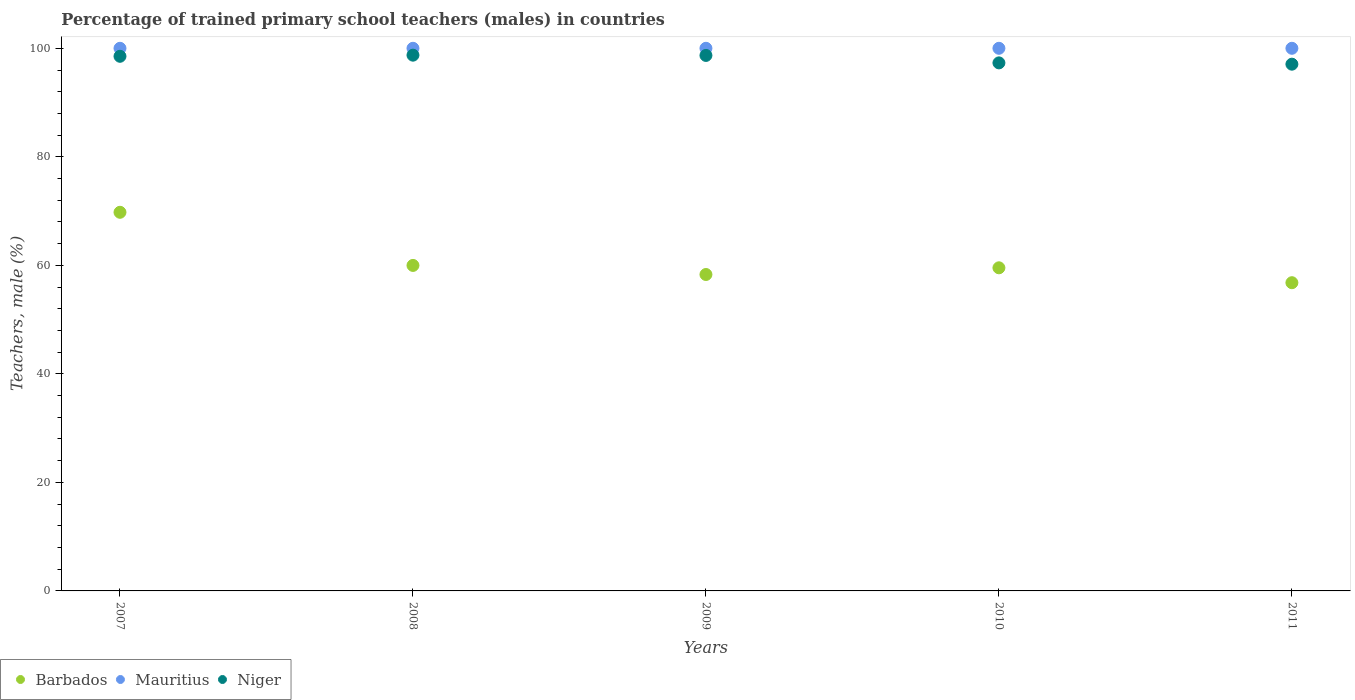Is the number of dotlines equal to the number of legend labels?
Make the answer very short. Yes. What is the percentage of trained primary school teachers (males) in Barbados in 2011?
Provide a succinct answer. 56.8. In which year was the percentage of trained primary school teachers (males) in Mauritius maximum?
Your response must be concise. 2007. What is the total percentage of trained primary school teachers (males) in Niger in the graph?
Ensure brevity in your answer.  490.33. What is the difference between the percentage of trained primary school teachers (males) in Niger in 2008 and that in 2009?
Make the answer very short. 0.05. What is the difference between the percentage of trained primary school teachers (males) in Niger in 2007 and the percentage of trained primary school teachers (males) in Barbados in 2008?
Ensure brevity in your answer.  38.54. What is the average percentage of trained primary school teachers (males) in Barbados per year?
Your answer should be compact. 60.88. In the year 2007, what is the difference between the percentage of trained primary school teachers (males) in Niger and percentage of trained primary school teachers (males) in Barbados?
Your response must be concise. 28.75. What is the ratio of the percentage of trained primary school teachers (males) in Niger in 2008 to that in 2009?
Offer a very short reply. 1. Is the percentage of trained primary school teachers (males) in Niger in 2007 less than that in 2011?
Keep it short and to the point. No. Is the difference between the percentage of trained primary school teachers (males) in Niger in 2009 and 2011 greater than the difference between the percentage of trained primary school teachers (males) in Barbados in 2009 and 2011?
Your answer should be very brief. Yes. What is the difference between the highest and the lowest percentage of trained primary school teachers (males) in Barbados?
Offer a very short reply. 12.98. In how many years, is the percentage of trained primary school teachers (males) in Barbados greater than the average percentage of trained primary school teachers (males) in Barbados taken over all years?
Provide a short and direct response. 1. Does the percentage of trained primary school teachers (males) in Barbados monotonically increase over the years?
Provide a short and direct response. No. Is the percentage of trained primary school teachers (males) in Niger strictly greater than the percentage of trained primary school teachers (males) in Mauritius over the years?
Provide a succinct answer. No. How many dotlines are there?
Make the answer very short. 3. Does the graph contain grids?
Give a very brief answer. No. How many legend labels are there?
Your answer should be very brief. 3. How are the legend labels stacked?
Your answer should be very brief. Horizontal. What is the title of the graph?
Offer a very short reply. Percentage of trained primary school teachers (males) in countries. Does "Pacific island small states" appear as one of the legend labels in the graph?
Give a very brief answer. No. What is the label or title of the X-axis?
Your response must be concise. Years. What is the label or title of the Y-axis?
Offer a terse response. Teachers, male (%). What is the Teachers, male (%) of Barbados in 2007?
Keep it short and to the point. 69.78. What is the Teachers, male (%) of Niger in 2007?
Ensure brevity in your answer.  98.53. What is the Teachers, male (%) in Barbados in 2008?
Provide a short and direct response. 59.99. What is the Teachers, male (%) in Niger in 2008?
Keep it short and to the point. 98.73. What is the Teachers, male (%) in Barbados in 2009?
Give a very brief answer. 58.31. What is the Teachers, male (%) of Mauritius in 2009?
Offer a very short reply. 100. What is the Teachers, male (%) in Niger in 2009?
Provide a short and direct response. 98.68. What is the Teachers, male (%) in Barbados in 2010?
Provide a succinct answer. 59.55. What is the Teachers, male (%) in Mauritius in 2010?
Make the answer very short. 100. What is the Teachers, male (%) in Niger in 2010?
Provide a short and direct response. 97.31. What is the Teachers, male (%) in Barbados in 2011?
Provide a succinct answer. 56.8. What is the Teachers, male (%) in Niger in 2011?
Your answer should be very brief. 97.07. Across all years, what is the maximum Teachers, male (%) of Barbados?
Provide a short and direct response. 69.78. Across all years, what is the maximum Teachers, male (%) in Mauritius?
Your answer should be very brief. 100. Across all years, what is the maximum Teachers, male (%) of Niger?
Ensure brevity in your answer.  98.73. Across all years, what is the minimum Teachers, male (%) of Barbados?
Make the answer very short. 56.8. Across all years, what is the minimum Teachers, male (%) of Niger?
Ensure brevity in your answer.  97.07. What is the total Teachers, male (%) in Barbados in the graph?
Offer a very short reply. 304.42. What is the total Teachers, male (%) of Niger in the graph?
Your response must be concise. 490.33. What is the difference between the Teachers, male (%) of Barbados in 2007 and that in 2008?
Ensure brevity in your answer.  9.79. What is the difference between the Teachers, male (%) of Niger in 2007 and that in 2008?
Ensure brevity in your answer.  -0.21. What is the difference between the Teachers, male (%) in Barbados in 2007 and that in 2009?
Offer a terse response. 11.46. What is the difference between the Teachers, male (%) of Mauritius in 2007 and that in 2009?
Provide a succinct answer. 0. What is the difference between the Teachers, male (%) in Niger in 2007 and that in 2009?
Make the answer very short. -0.16. What is the difference between the Teachers, male (%) in Barbados in 2007 and that in 2010?
Your response must be concise. 10.23. What is the difference between the Teachers, male (%) of Niger in 2007 and that in 2010?
Make the answer very short. 1.21. What is the difference between the Teachers, male (%) of Barbados in 2007 and that in 2011?
Keep it short and to the point. 12.98. What is the difference between the Teachers, male (%) in Mauritius in 2007 and that in 2011?
Make the answer very short. 0. What is the difference between the Teachers, male (%) in Niger in 2007 and that in 2011?
Offer a very short reply. 1.45. What is the difference between the Teachers, male (%) of Barbados in 2008 and that in 2009?
Make the answer very short. 1.67. What is the difference between the Teachers, male (%) in Niger in 2008 and that in 2009?
Give a very brief answer. 0.05. What is the difference between the Teachers, male (%) in Barbados in 2008 and that in 2010?
Keep it short and to the point. 0.44. What is the difference between the Teachers, male (%) in Mauritius in 2008 and that in 2010?
Your response must be concise. 0. What is the difference between the Teachers, male (%) of Niger in 2008 and that in 2010?
Give a very brief answer. 1.42. What is the difference between the Teachers, male (%) in Barbados in 2008 and that in 2011?
Give a very brief answer. 3.18. What is the difference between the Teachers, male (%) in Mauritius in 2008 and that in 2011?
Offer a very short reply. 0. What is the difference between the Teachers, male (%) of Niger in 2008 and that in 2011?
Your response must be concise. 1.66. What is the difference between the Teachers, male (%) in Barbados in 2009 and that in 2010?
Provide a succinct answer. -1.23. What is the difference between the Teachers, male (%) in Mauritius in 2009 and that in 2010?
Ensure brevity in your answer.  0. What is the difference between the Teachers, male (%) of Niger in 2009 and that in 2010?
Your response must be concise. 1.37. What is the difference between the Teachers, male (%) of Barbados in 2009 and that in 2011?
Provide a succinct answer. 1.51. What is the difference between the Teachers, male (%) in Niger in 2009 and that in 2011?
Ensure brevity in your answer.  1.61. What is the difference between the Teachers, male (%) of Barbados in 2010 and that in 2011?
Your answer should be very brief. 2.75. What is the difference between the Teachers, male (%) in Niger in 2010 and that in 2011?
Provide a short and direct response. 0.24. What is the difference between the Teachers, male (%) of Barbados in 2007 and the Teachers, male (%) of Mauritius in 2008?
Your response must be concise. -30.22. What is the difference between the Teachers, male (%) of Barbados in 2007 and the Teachers, male (%) of Niger in 2008?
Keep it short and to the point. -28.96. What is the difference between the Teachers, male (%) in Mauritius in 2007 and the Teachers, male (%) in Niger in 2008?
Provide a short and direct response. 1.27. What is the difference between the Teachers, male (%) in Barbados in 2007 and the Teachers, male (%) in Mauritius in 2009?
Ensure brevity in your answer.  -30.22. What is the difference between the Teachers, male (%) of Barbados in 2007 and the Teachers, male (%) of Niger in 2009?
Your answer should be very brief. -28.91. What is the difference between the Teachers, male (%) of Mauritius in 2007 and the Teachers, male (%) of Niger in 2009?
Your response must be concise. 1.32. What is the difference between the Teachers, male (%) in Barbados in 2007 and the Teachers, male (%) in Mauritius in 2010?
Your answer should be compact. -30.22. What is the difference between the Teachers, male (%) in Barbados in 2007 and the Teachers, male (%) in Niger in 2010?
Your answer should be compact. -27.53. What is the difference between the Teachers, male (%) of Mauritius in 2007 and the Teachers, male (%) of Niger in 2010?
Offer a very short reply. 2.69. What is the difference between the Teachers, male (%) of Barbados in 2007 and the Teachers, male (%) of Mauritius in 2011?
Provide a short and direct response. -30.22. What is the difference between the Teachers, male (%) in Barbados in 2007 and the Teachers, male (%) in Niger in 2011?
Ensure brevity in your answer.  -27.3. What is the difference between the Teachers, male (%) of Mauritius in 2007 and the Teachers, male (%) of Niger in 2011?
Ensure brevity in your answer.  2.93. What is the difference between the Teachers, male (%) in Barbados in 2008 and the Teachers, male (%) in Mauritius in 2009?
Your answer should be very brief. -40.01. What is the difference between the Teachers, male (%) of Barbados in 2008 and the Teachers, male (%) of Niger in 2009?
Make the answer very short. -38.7. What is the difference between the Teachers, male (%) of Mauritius in 2008 and the Teachers, male (%) of Niger in 2009?
Provide a short and direct response. 1.32. What is the difference between the Teachers, male (%) of Barbados in 2008 and the Teachers, male (%) of Mauritius in 2010?
Your answer should be very brief. -40.01. What is the difference between the Teachers, male (%) of Barbados in 2008 and the Teachers, male (%) of Niger in 2010?
Your answer should be compact. -37.33. What is the difference between the Teachers, male (%) of Mauritius in 2008 and the Teachers, male (%) of Niger in 2010?
Ensure brevity in your answer.  2.69. What is the difference between the Teachers, male (%) in Barbados in 2008 and the Teachers, male (%) in Mauritius in 2011?
Offer a terse response. -40.01. What is the difference between the Teachers, male (%) in Barbados in 2008 and the Teachers, male (%) in Niger in 2011?
Give a very brief answer. -37.09. What is the difference between the Teachers, male (%) in Mauritius in 2008 and the Teachers, male (%) in Niger in 2011?
Make the answer very short. 2.93. What is the difference between the Teachers, male (%) in Barbados in 2009 and the Teachers, male (%) in Mauritius in 2010?
Your response must be concise. -41.69. What is the difference between the Teachers, male (%) of Barbados in 2009 and the Teachers, male (%) of Niger in 2010?
Ensure brevity in your answer.  -39. What is the difference between the Teachers, male (%) in Mauritius in 2009 and the Teachers, male (%) in Niger in 2010?
Offer a terse response. 2.69. What is the difference between the Teachers, male (%) of Barbados in 2009 and the Teachers, male (%) of Mauritius in 2011?
Make the answer very short. -41.69. What is the difference between the Teachers, male (%) in Barbados in 2009 and the Teachers, male (%) in Niger in 2011?
Give a very brief answer. -38.76. What is the difference between the Teachers, male (%) in Mauritius in 2009 and the Teachers, male (%) in Niger in 2011?
Provide a short and direct response. 2.93. What is the difference between the Teachers, male (%) of Barbados in 2010 and the Teachers, male (%) of Mauritius in 2011?
Your answer should be very brief. -40.45. What is the difference between the Teachers, male (%) in Barbados in 2010 and the Teachers, male (%) in Niger in 2011?
Offer a very short reply. -37.53. What is the difference between the Teachers, male (%) of Mauritius in 2010 and the Teachers, male (%) of Niger in 2011?
Your answer should be compact. 2.93. What is the average Teachers, male (%) in Barbados per year?
Give a very brief answer. 60.88. What is the average Teachers, male (%) in Mauritius per year?
Offer a very short reply. 100. What is the average Teachers, male (%) of Niger per year?
Offer a very short reply. 98.07. In the year 2007, what is the difference between the Teachers, male (%) in Barbados and Teachers, male (%) in Mauritius?
Make the answer very short. -30.22. In the year 2007, what is the difference between the Teachers, male (%) of Barbados and Teachers, male (%) of Niger?
Make the answer very short. -28.75. In the year 2007, what is the difference between the Teachers, male (%) in Mauritius and Teachers, male (%) in Niger?
Give a very brief answer. 1.47. In the year 2008, what is the difference between the Teachers, male (%) of Barbados and Teachers, male (%) of Mauritius?
Make the answer very short. -40.01. In the year 2008, what is the difference between the Teachers, male (%) in Barbados and Teachers, male (%) in Niger?
Your answer should be very brief. -38.75. In the year 2008, what is the difference between the Teachers, male (%) of Mauritius and Teachers, male (%) of Niger?
Keep it short and to the point. 1.27. In the year 2009, what is the difference between the Teachers, male (%) in Barbados and Teachers, male (%) in Mauritius?
Your response must be concise. -41.69. In the year 2009, what is the difference between the Teachers, male (%) of Barbados and Teachers, male (%) of Niger?
Offer a terse response. -40.37. In the year 2009, what is the difference between the Teachers, male (%) of Mauritius and Teachers, male (%) of Niger?
Make the answer very short. 1.32. In the year 2010, what is the difference between the Teachers, male (%) of Barbados and Teachers, male (%) of Mauritius?
Your response must be concise. -40.45. In the year 2010, what is the difference between the Teachers, male (%) in Barbados and Teachers, male (%) in Niger?
Ensure brevity in your answer.  -37.77. In the year 2010, what is the difference between the Teachers, male (%) in Mauritius and Teachers, male (%) in Niger?
Make the answer very short. 2.69. In the year 2011, what is the difference between the Teachers, male (%) of Barbados and Teachers, male (%) of Mauritius?
Give a very brief answer. -43.2. In the year 2011, what is the difference between the Teachers, male (%) in Barbados and Teachers, male (%) in Niger?
Your answer should be compact. -40.27. In the year 2011, what is the difference between the Teachers, male (%) of Mauritius and Teachers, male (%) of Niger?
Offer a terse response. 2.93. What is the ratio of the Teachers, male (%) in Barbados in 2007 to that in 2008?
Your response must be concise. 1.16. What is the ratio of the Teachers, male (%) in Niger in 2007 to that in 2008?
Keep it short and to the point. 1. What is the ratio of the Teachers, male (%) in Barbados in 2007 to that in 2009?
Keep it short and to the point. 1.2. What is the ratio of the Teachers, male (%) of Mauritius in 2007 to that in 2009?
Make the answer very short. 1. What is the ratio of the Teachers, male (%) in Barbados in 2007 to that in 2010?
Provide a succinct answer. 1.17. What is the ratio of the Teachers, male (%) of Mauritius in 2007 to that in 2010?
Your answer should be very brief. 1. What is the ratio of the Teachers, male (%) of Niger in 2007 to that in 2010?
Offer a very short reply. 1.01. What is the ratio of the Teachers, male (%) of Barbados in 2007 to that in 2011?
Your response must be concise. 1.23. What is the ratio of the Teachers, male (%) of Mauritius in 2007 to that in 2011?
Your answer should be compact. 1. What is the ratio of the Teachers, male (%) in Niger in 2007 to that in 2011?
Ensure brevity in your answer.  1.01. What is the ratio of the Teachers, male (%) in Barbados in 2008 to that in 2009?
Ensure brevity in your answer.  1.03. What is the ratio of the Teachers, male (%) of Barbados in 2008 to that in 2010?
Provide a succinct answer. 1.01. What is the ratio of the Teachers, male (%) in Mauritius in 2008 to that in 2010?
Your answer should be very brief. 1. What is the ratio of the Teachers, male (%) in Niger in 2008 to that in 2010?
Offer a very short reply. 1.01. What is the ratio of the Teachers, male (%) in Barbados in 2008 to that in 2011?
Offer a very short reply. 1.06. What is the ratio of the Teachers, male (%) in Mauritius in 2008 to that in 2011?
Provide a short and direct response. 1. What is the ratio of the Teachers, male (%) of Niger in 2008 to that in 2011?
Provide a succinct answer. 1.02. What is the ratio of the Teachers, male (%) in Barbados in 2009 to that in 2010?
Provide a short and direct response. 0.98. What is the ratio of the Teachers, male (%) in Mauritius in 2009 to that in 2010?
Your answer should be compact. 1. What is the ratio of the Teachers, male (%) in Niger in 2009 to that in 2010?
Ensure brevity in your answer.  1.01. What is the ratio of the Teachers, male (%) in Barbados in 2009 to that in 2011?
Your answer should be compact. 1.03. What is the ratio of the Teachers, male (%) of Mauritius in 2009 to that in 2011?
Ensure brevity in your answer.  1. What is the ratio of the Teachers, male (%) in Niger in 2009 to that in 2011?
Give a very brief answer. 1.02. What is the ratio of the Teachers, male (%) of Barbados in 2010 to that in 2011?
Offer a terse response. 1.05. What is the difference between the highest and the second highest Teachers, male (%) of Barbados?
Your answer should be compact. 9.79. What is the difference between the highest and the second highest Teachers, male (%) of Niger?
Provide a short and direct response. 0.05. What is the difference between the highest and the lowest Teachers, male (%) in Barbados?
Your answer should be very brief. 12.98. What is the difference between the highest and the lowest Teachers, male (%) in Niger?
Your answer should be compact. 1.66. 